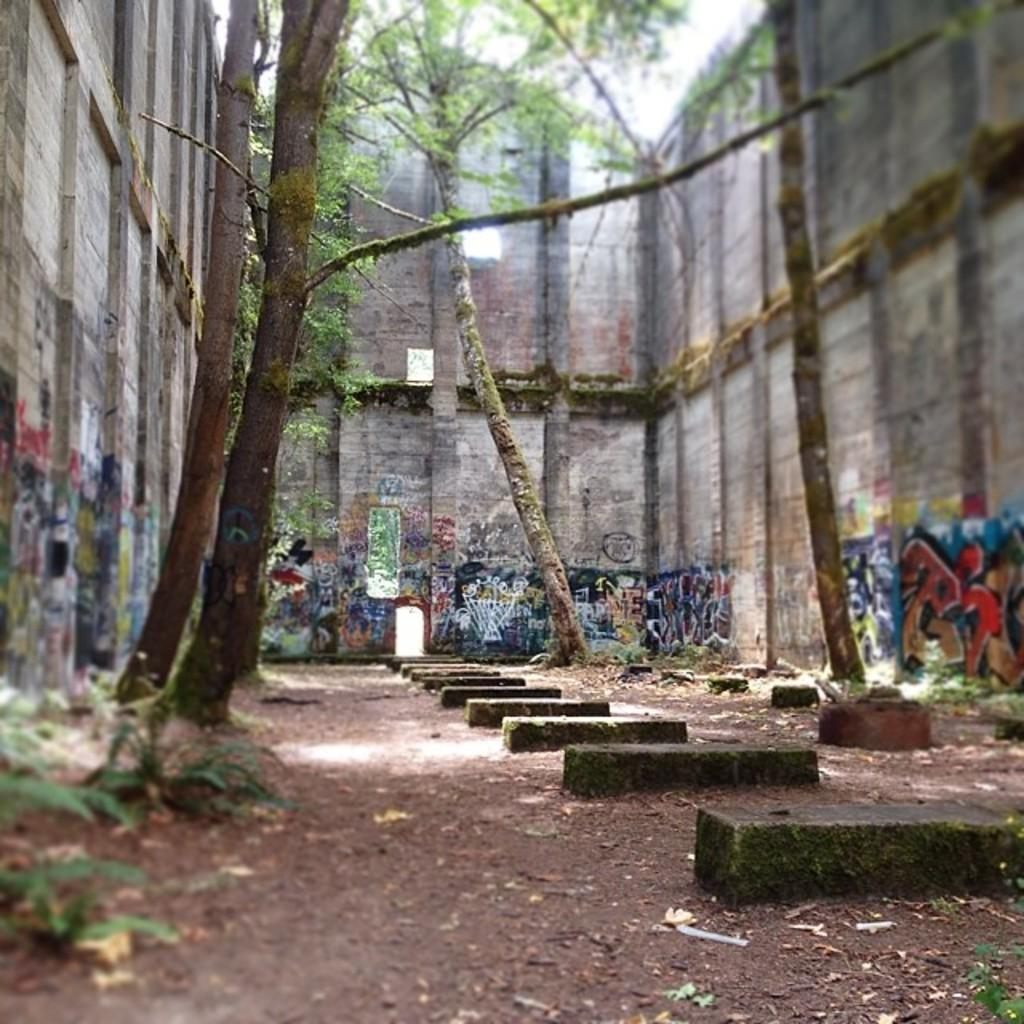What type of vegetation can be seen in the image? There are trees and plants in the image. What structures are present in the image? There are walls in the image. What is on the walls in the image? There is graffiti on the walls. What type of ground surface is visible in the image? There are stones on the ground in the image. How many dimes can be seen on the ground in the image? There are no dimes present in the image. What word is written in the graffiti on the walls? The provided facts do not mention any specific words in the graffiti, so we cannot answer this question. --- Facts: 1. There is a person in the image. 2. The person is wearing a hat. 3. The person is holding a book. 4. There is a table in the image. 5. The table has a lamp on it. Absurd Topics: parrot, ocean, bicycle Conversation: What is the main subject of the image? The main subject of the image is a person. What is the person wearing in the image? The person is wearing a hat in the image. What is the person holding in the image? The person is holding a book in the image. What piece of furniture is present in the image? There is a table in the image. What object is on the table in the image? The table has a lamp on it. Reasoning: Let's think step by step in order to produce the conversation. We start by identifying the main subject in the image, which is the person. Then, we expand the conversation to include other items that are also visible, such as the hat, book, table, and lamp. Each question is designed to elicit a specific detail about the image that is known from the provided facts. Absurd Question/Answer: Can you see a parrot sitting on the person's shoulder in the image? No, there is no parrot present in the image. Is the person riding a bicycle in the image? No, there is no bicycle present in the image. 